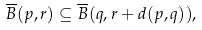Convert formula to latex. <formula><loc_0><loc_0><loc_500><loc_500>\overline { B } ( p , r ) \subseteq \overline { B } ( q , r + d ( p , q ) ) ,</formula> 